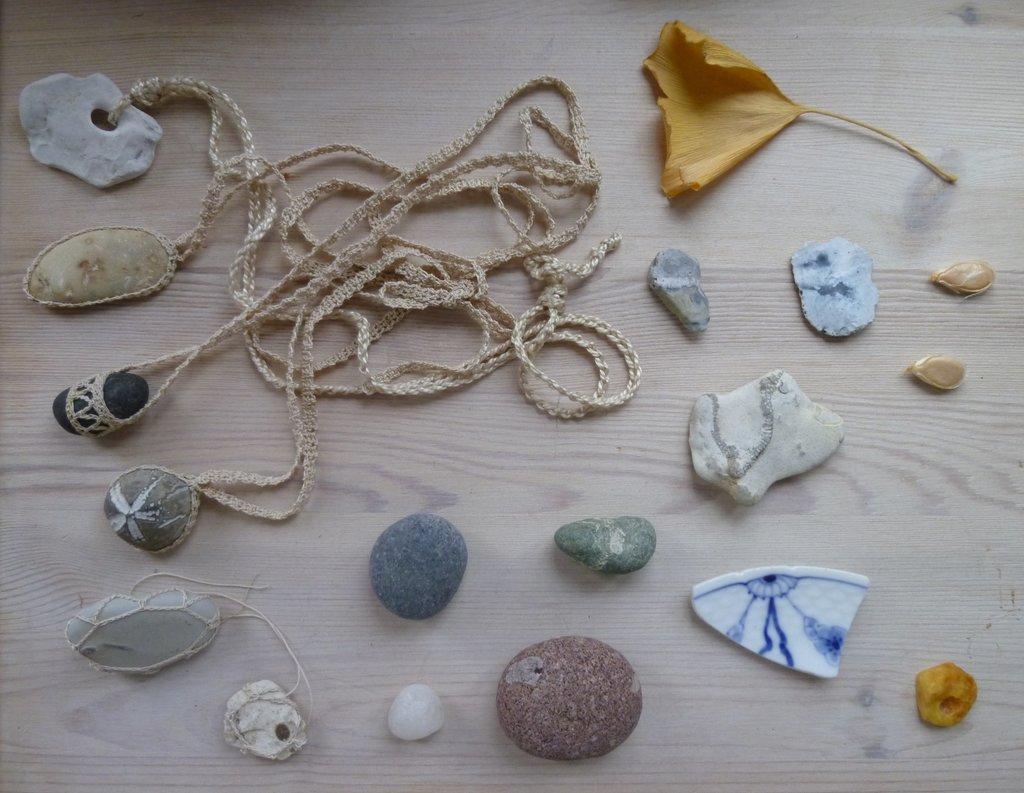Could you give a brief overview of what you see in this image? In this image, I can see different types of pebbles. This is a dried leaf, which is yellow in color. I think these are the seeds. I think this is the thread, which is tied to few of the pebbles. In the background, I think this is a wooden board. 